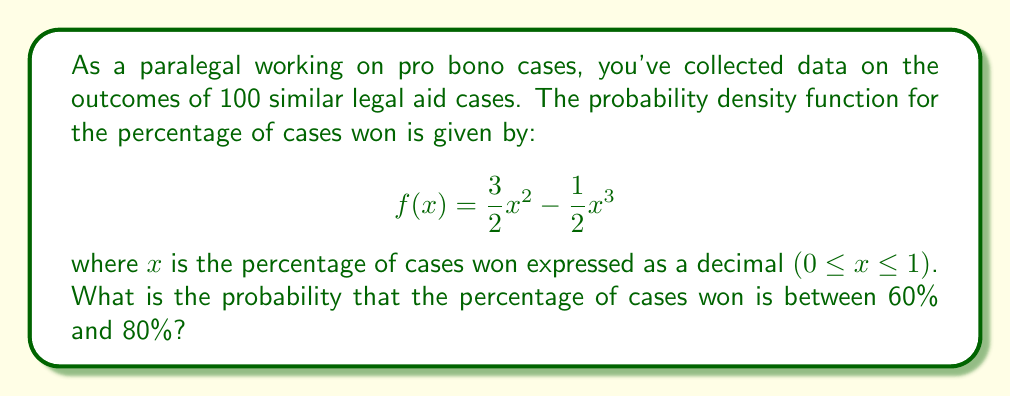Show me your answer to this math problem. To solve this problem, we need to integrate the probability density function over the given interval. Here's the step-by-step solution:

1) We need to find the probability that x is between 0.6 and 0.8 (since the percentages are expressed as decimals in the function).

2) This probability is given by the definite integral of f(x) from 0.6 to 0.8:

   $$P(0.6 \leq x \leq 0.8) = \int_{0.6}^{0.8} (\frac{3}{2}x^2 - \frac{1}{2}x^3) dx$$

3) Let's integrate this function:

   $$\int (\frac{3}{2}x^2 - \frac{1}{2}x^3) dx = \frac{1}{2}x^3 - \frac{1}{8}x^4 + C$$

4) Now, we can apply the limits:

   $$[\frac{1}{2}x^3 - \frac{1}{8}x^4]_{0.6}^{0.8}$$

5) Let's calculate the values at each limit:

   At x = 0.8: $\frac{1}{2}(0.8)^3 - \frac{1}{8}(0.8)^4 = 0.2048 - 0.04096 = 0.16384$

   At x = 0.6: $\frac{1}{2}(0.6)^3 - \frac{1}{8}(0.6)^4 = 0.108 - 0.01296 = 0.09504$

6) Subtracting these values:

   $0.16384 - 0.09504 = 0.0688$

Therefore, the probability that the percentage of cases won is between 60% and 80% is 0.0688 or 6.88%.
Answer: 0.0688 